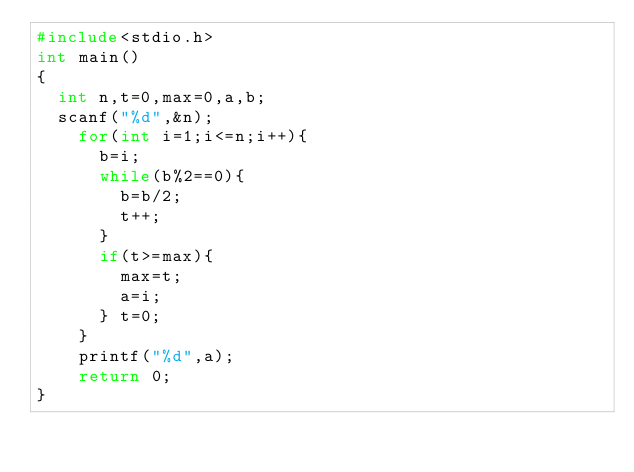<code> <loc_0><loc_0><loc_500><loc_500><_C_>#include<stdio.h>
int main()
{
	int n,t=0,max=0,a,b;
	scanf("%d",&n);
		for(int i=1;i<=n;i++){
			b=i;
			while(b%2==0){
				b=b/2;
				t++;
			}
			if(t>=max){
				max=t;
				a=i;
			} t=0;
		}
		printf("%d",a);
		return 0;	
}</code> 